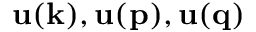Convert formula to latex. <formula><loc_0><loc_0><loc_500><loc_500>{ u ( k ) } , { u ( p ) } , { u ( q ) }</formula> 